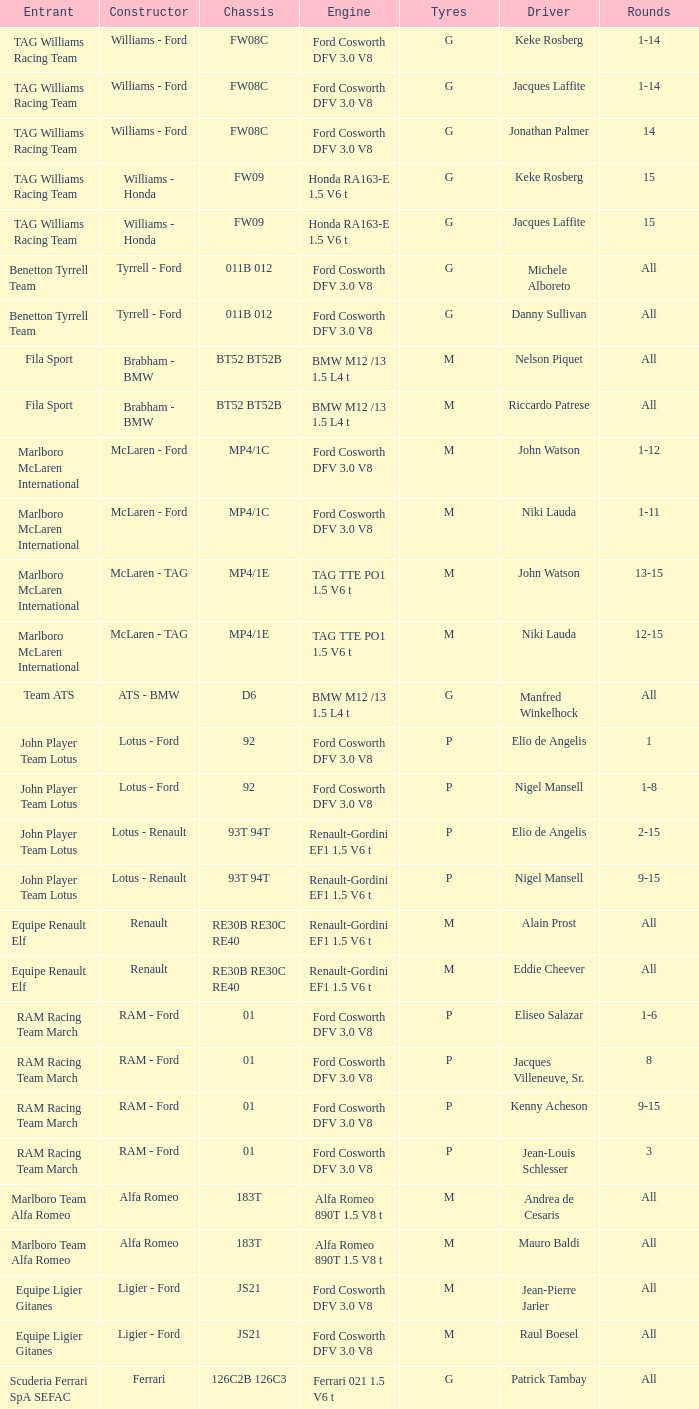Who is the controller of the d6 chassis? Manfred Winkelhock. 